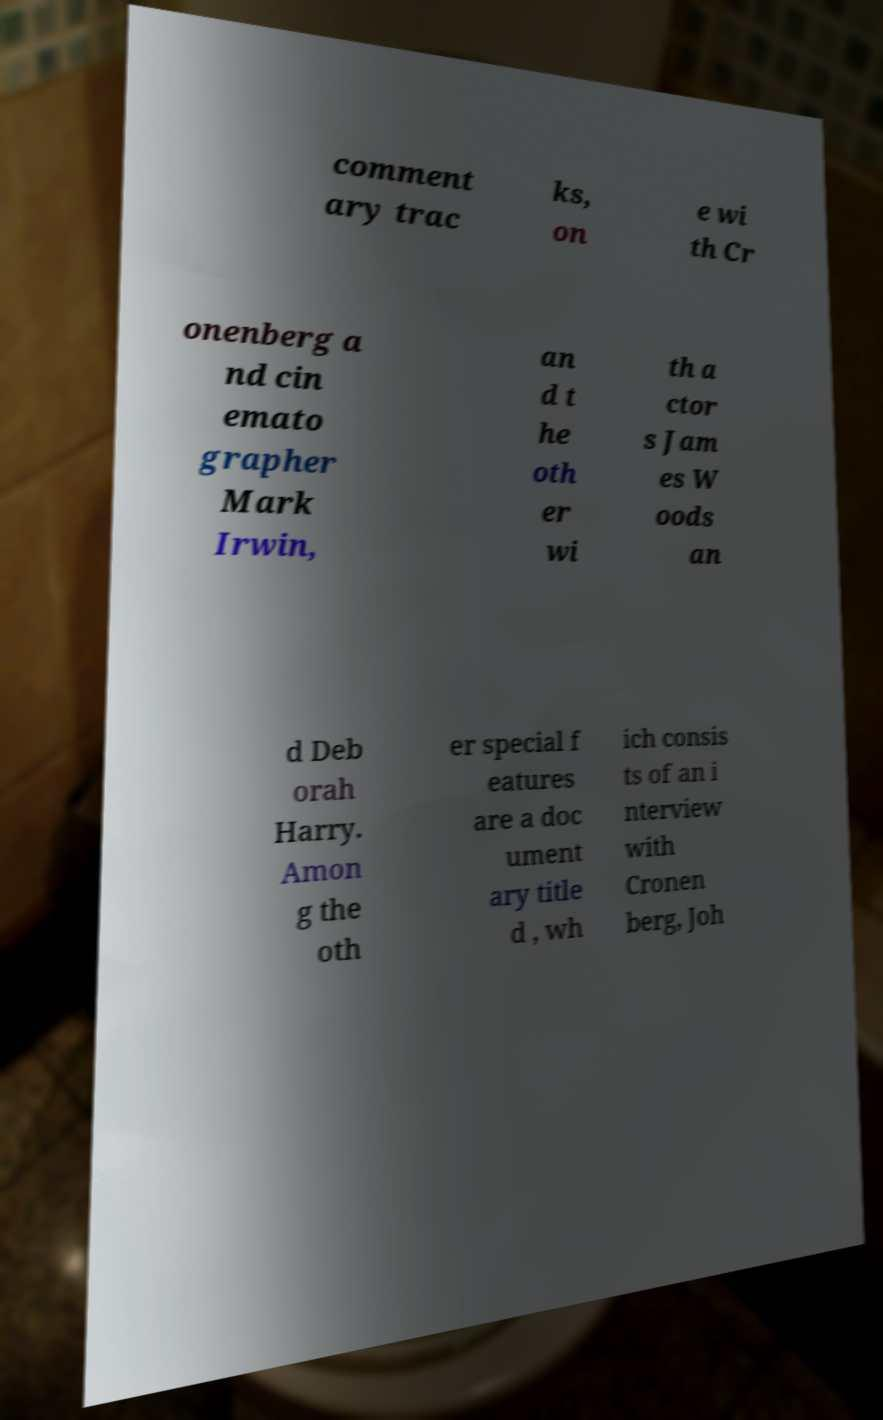Could you extract and type out the text from this image? comment ary trac ks, on e wi th Cr onenberg a nd cin emato grapher Mark Irwin, an d t he oth er wi th a ctor s Jam es W oods an d Deb orah Harry. Amon g the oth er special f eatures are a doc ument ary title d , wh ich consis ts of an i nterview with Cronen berg, Joh 